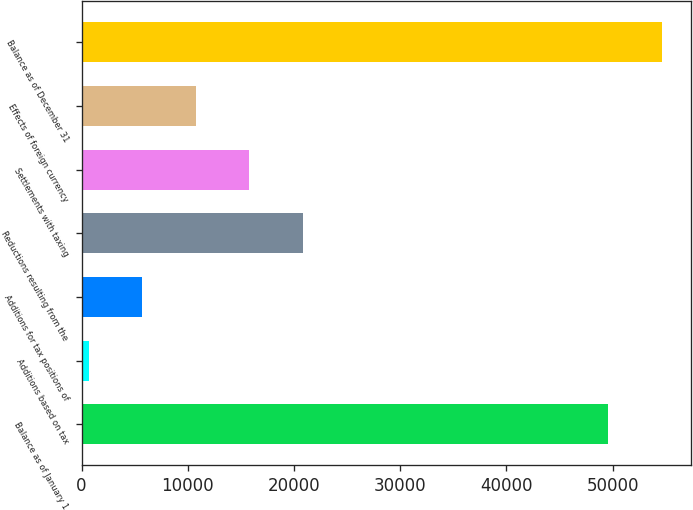Convert chart to OTSL. <chart><loc_0><loc_0><loc_500><loc_500><bar_chart><fcel>Balance as of January 1<fcel>Additions based on tax<fcel>Additions for tax positions of<fcel>Reductions resulting from the<fcel>Settlements with taxing<fcel>Effects of foreign currency<fcel>Balance as of December 31<nl><fcel>49599<fcel>684<fcel>5719.3<fcel>20825.2<fcel>15789.9<fcel>10754.6<fcel>54634.3<nl></chart> 